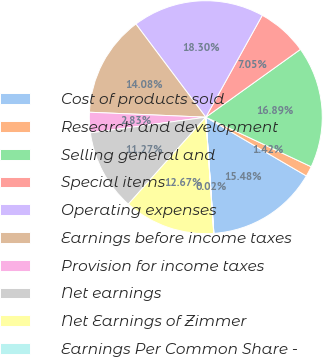Convert chart to OTSL. <chart><loc_0><loc_0><loc_500><loc_500><pie_chart><fcel>Cost of products sold<fcel>Research and development<fcel>Selling general and<fcel>Special items<fcel>Operating expenses<fcel>Earnings before income taxes<fcel>Provision for income taxes<fcel>Net earnings<fcel>Net Earnings of Zimmer<fcel>Earnings Per Common Share -<nl><fcel>15.48%<fcel>1.42%<fcel>16.89%<fcel>7.05%<fcel>18.3%<fcel>14.08%<fcel>2.83%<fcel>11.27%<fcel>12.67%<fcel>0.02%<nl></chart> 